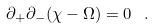<formula> <loc_0><loc_0><loc_500><loc_500>\partial _ { + } \partial _ { - } ( \chi - \Omega ) = 0 \ \ .</formula> 